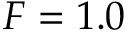Convert formula to latex. <formula><loc_0><loc_0><loc_500><loc_500>F = 1 . 0</formula> 